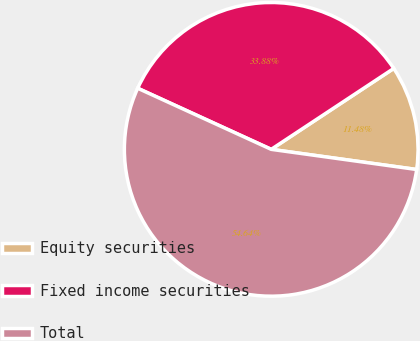Convert chart to OTSL. <chart><loc_0><loc_0><loc_500><loc_500><pie_chart><fcel>Equity securities<fcel>Fixed income securities<fcel>Total<nl><fcel>11.48%<fcel>33.88%<fcel>54.64%<nl></chart> 